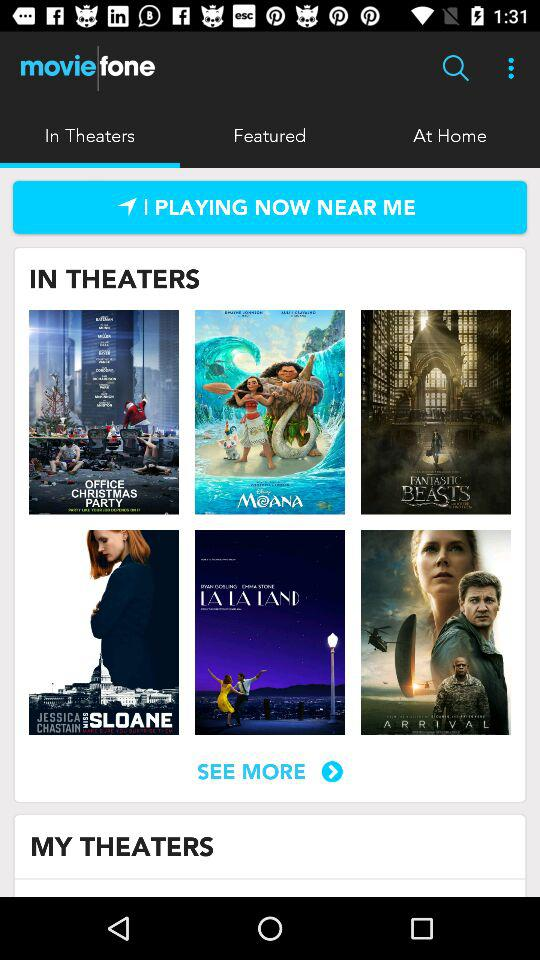What is the selected option? The selected option is "In Theaters". 